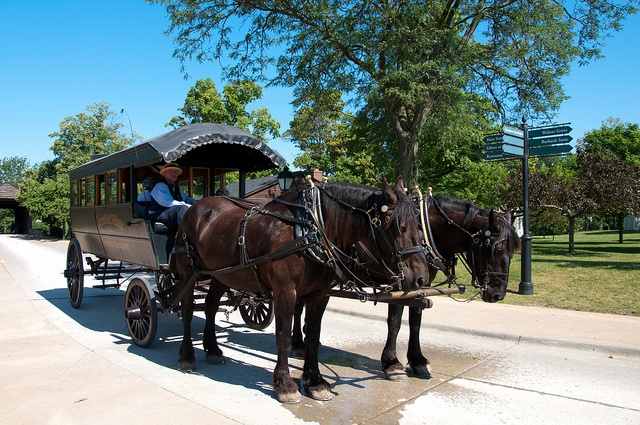Describe the objects in this image and their specific colors. I can see horse in lightblue, black, gray, maroon, and darkgray tones, horse in lightblue, black, gray, and darkgray tones, people in lightblue, black, blue, navy, and maroon tones, and people in lightblue, black, blue, and navy tones in this image. 